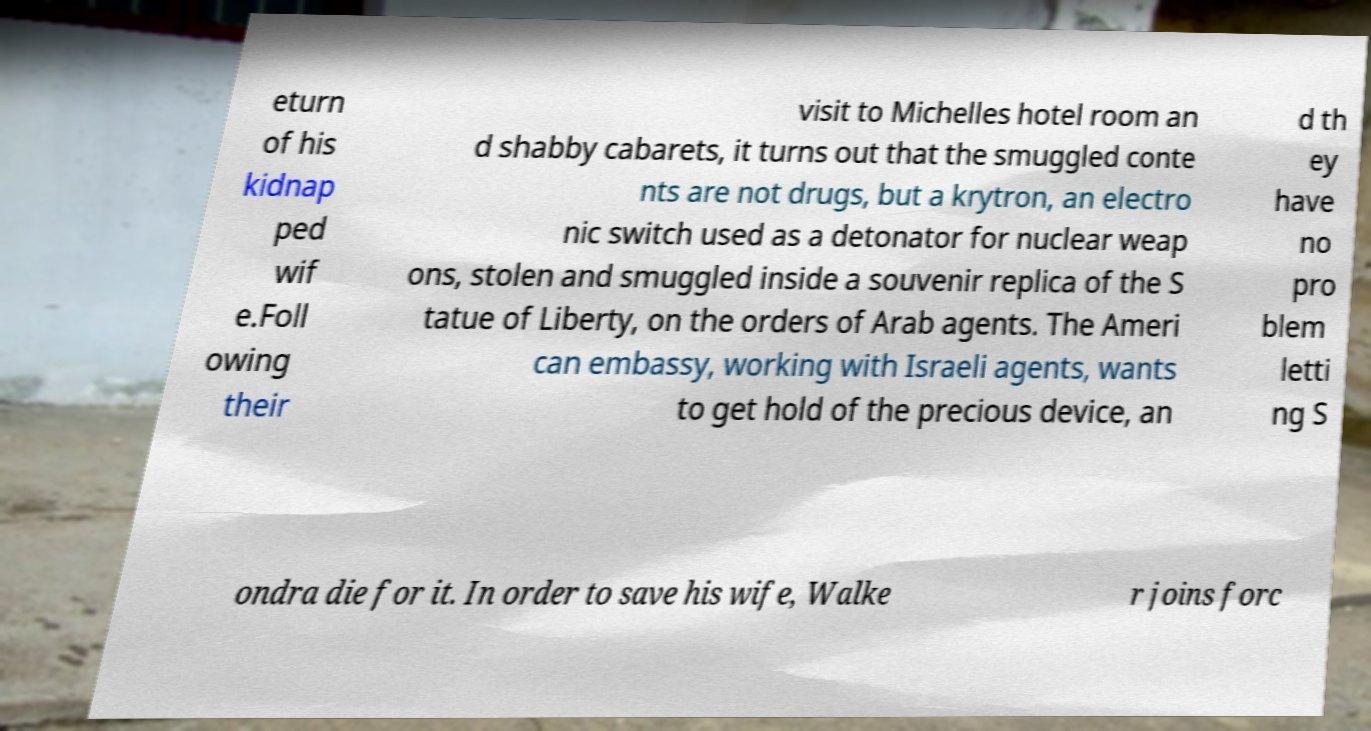For documentation purposes, I need the text within this image transcribed. Could you provide that? eturn of his kidnap ped wif e.Foll owing their visit to Michelles hotel room an d shabby cabarets, it turns out that the smuggled conte nts are not drugs, but a krytron, an electro nic switch used as a detonator for nuclear weap ons, stolen and smuggled inside a souvenir replica of the S tatue of Liberty, on the orders of Arab agents. The Ameri can embassy, working with Israeli agents, wants to get hold of the precious device, an d th ey have no pro blem letti ng S ondra die for it. In order to save his wife, Walke r joins forc 